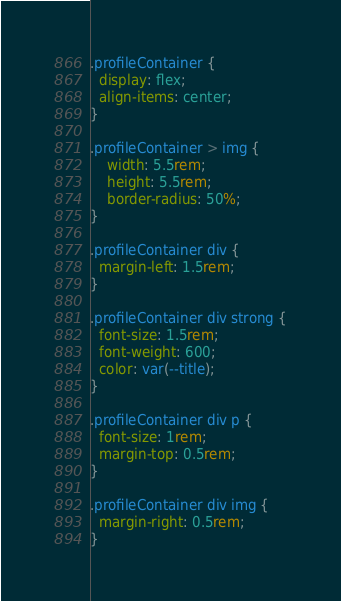Convert code to text. <code><loc_0><loc_0><loc_500><loc_500><_CSS_>.profileContainer {
  display: flex;
  align-items: center;
}

.profileContainer > img {
    width: 5.5rem;
    height: 5.5rem;
    border-radius: 50%;
}

.profileContainer div {
  margin-left: 1.5rem;
}

.profileContainer div strong {
  font-size: 1.5rem;
  font-weight: 600;
  color: var(--title);
}

.profileContainer div p {
  font-size: 1rem;
  margin-top: 0.5rem;
}

.profileContainer div img {
  margin-right: 0.5rem;
}
</code> 